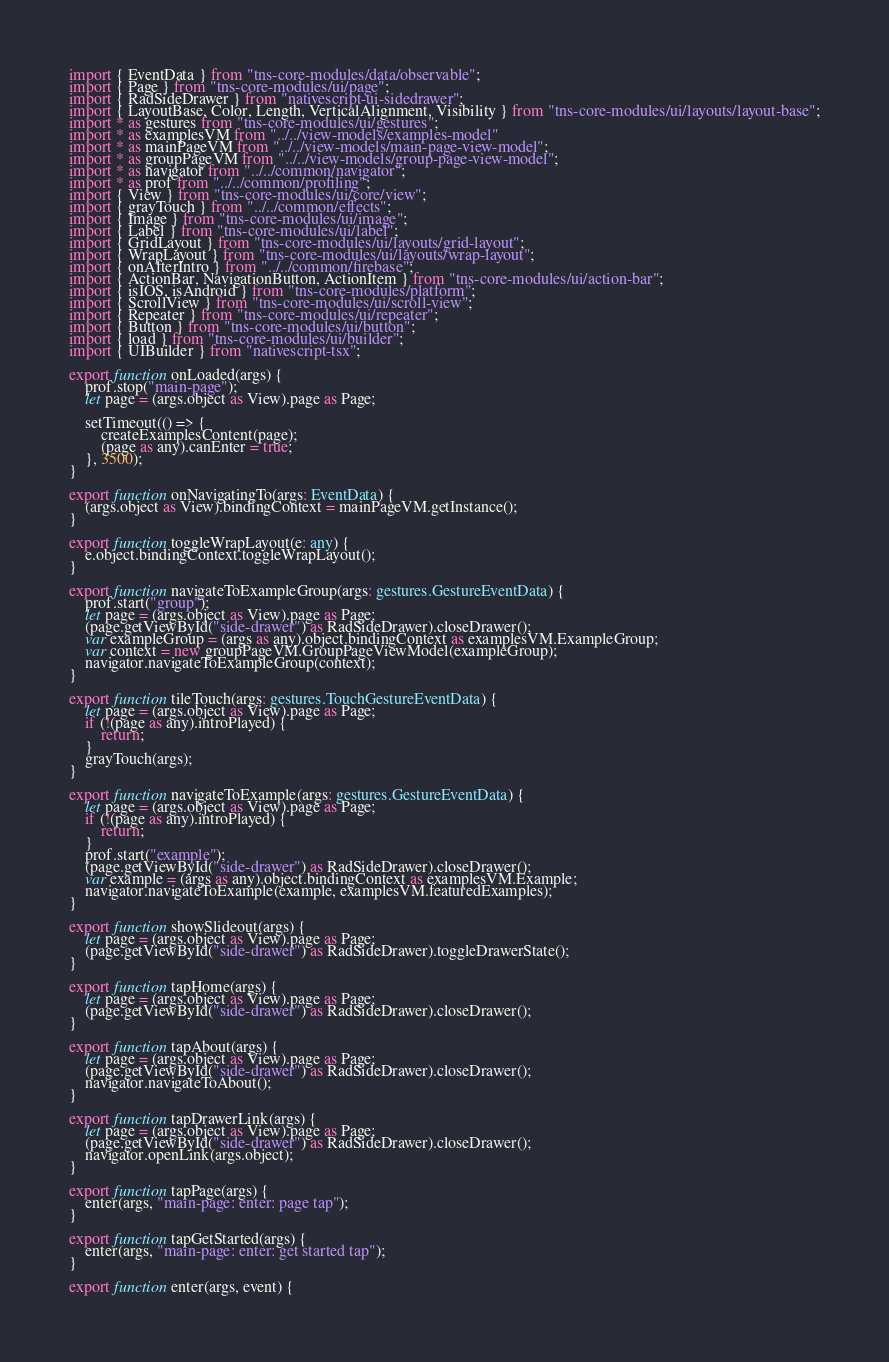<code> <loc_0><loc_0><loc_500><loc_500><_TypeScript_>import { EventData } from "tns-core-modules/data/observable";
import { Page } from "tns-core-modules/ui/page";
import { RadSideDrawer } from "nativescript-ui-sidedrawer";
import { LayoutBase, Color, Length, VerticalAlignment, Visibility } from "tns-core-modules/ui/layouts/layout-base";
import * as gestures from "tns-core-modules/ui/gestures";
import * as examplesVM from "../../view-models/examples-model"
import * as mainPageVM from "../../view-models/main-page-view-model";
import * as groupPageVM from "../../view-models/group-page-view-model";
import * as navigator from "../../common/navigator";
import * as prof from "../../common/profiling";
import { View } from "tns-core-modules/ui/core/view";
import { grayTouch } from "../../common/effects";
import { Image } from "tns-core-modules/ui/image";
import { Label } from "tns-core-modules/ui/label";
import { GridLayout } from "tns-core-modules/ui/layouts/grid-layout";
import { WrapLayout } from "tns-core-modules/ui/layouts/wrap-layout";
import { onAfterIntro } from "../../common/firebase";
import { ActionBar, NavigationButton, ActionItem } from "tns-core-modules/ui/action-bar";
import { isIOS, isAndroid } from "tns-core-modules/platform";
import { ScrollView } from "tns-core-modules/ui/scroll-view";
import { Repeater } from "tns-core-modules/ui/repeater";
import { Button } from "tns-core-modules/ui/button";
import { load } from "tns-core-modules/ui/builder";
import { UIBuilder } from "nativescript-tsx";

export function onLoaded(args) {
    prof.stop("main-page");
    let page = (args.object as View).page as Page;

    setTimeout(() => {
        createExamplesContent(page);
        (page as any).canEnter = true;
    }, 3500);
}

export function onNavigatingTo(args: EventData) {
    (args.object as View).bindingContext = mainPageVM.getInstance();
}

export function toggleWrapLayout(e: any) {
    e.object.bindingContext.toggleWrapLayout();
}

export function navigateToExampleGroup(args: gestures.GestureEventData) {
    prof.start("group");
    let page = (args.object as View).page as Page;
    (page.getViewById("side-drawer") as RadSideDrawer).closeDrawer();
    var exampleGroup = (args as any).object.bindingContext as examplesVM.ExampleGroup;
    var context = new groupPageVM.GroupPageViewModel(exampleGroup);
    navigator.navigateToExampleGroup(context);
}

export function tileTouch(args: gestures.TouchGestureEventData) {
    let page = (args.object as View).page as Page;
    if (!(page as any).introPlayed) {
        return;
    }
    grayTouch(args);
}

export function navigateToExample(args: gestures.GestureEventData) {
    let page = (args.object as View).page as Page;
    if (!(page as any).introPlayed) {
        return;
    }
    prof.start("example");
    (page.getViewById("side-drawer") as RadSideDrawer).closeDrawer();
    var example = (args as any).object.bindingContext as examplesVM.Example;
    navigator.navigateToExample(example, examplesVM.featuredExamples);
}

export function showSlideout(args) {
    let page = (args.object as View).page as Page;
    (page.getViewById("side-drawer") as RadSideDrawer).toggleDrawerState();
}

export function tapHome(args) {
    let page = (args.object as View).page as Page;
    (page.getViewById("side-drawer") as RadSideDrawer).closeDrawer();
}

export function tapAbout(args) {
    let page = (args.object as View).page as Page;
    (page.getViewById("side-drawer") as RadSideDrawer).closeDrawer();
    navigator.navigateToAbout();
}

export function tapDrawerLink(args) {
    let page = (args.object as View).page as Page;
    (page.getViewById("side-drawer") as RadSideDrawer).closeDrawer();
    navigator.openLink(args.object);
}

export function tapPage(args) {
    enter(args, "main-page: enter: page tap");
}

export function tapGetStarted(args) {
    enter(args, "main-page: enter: get started tap");
}

export function enter(args, event) {</code> 